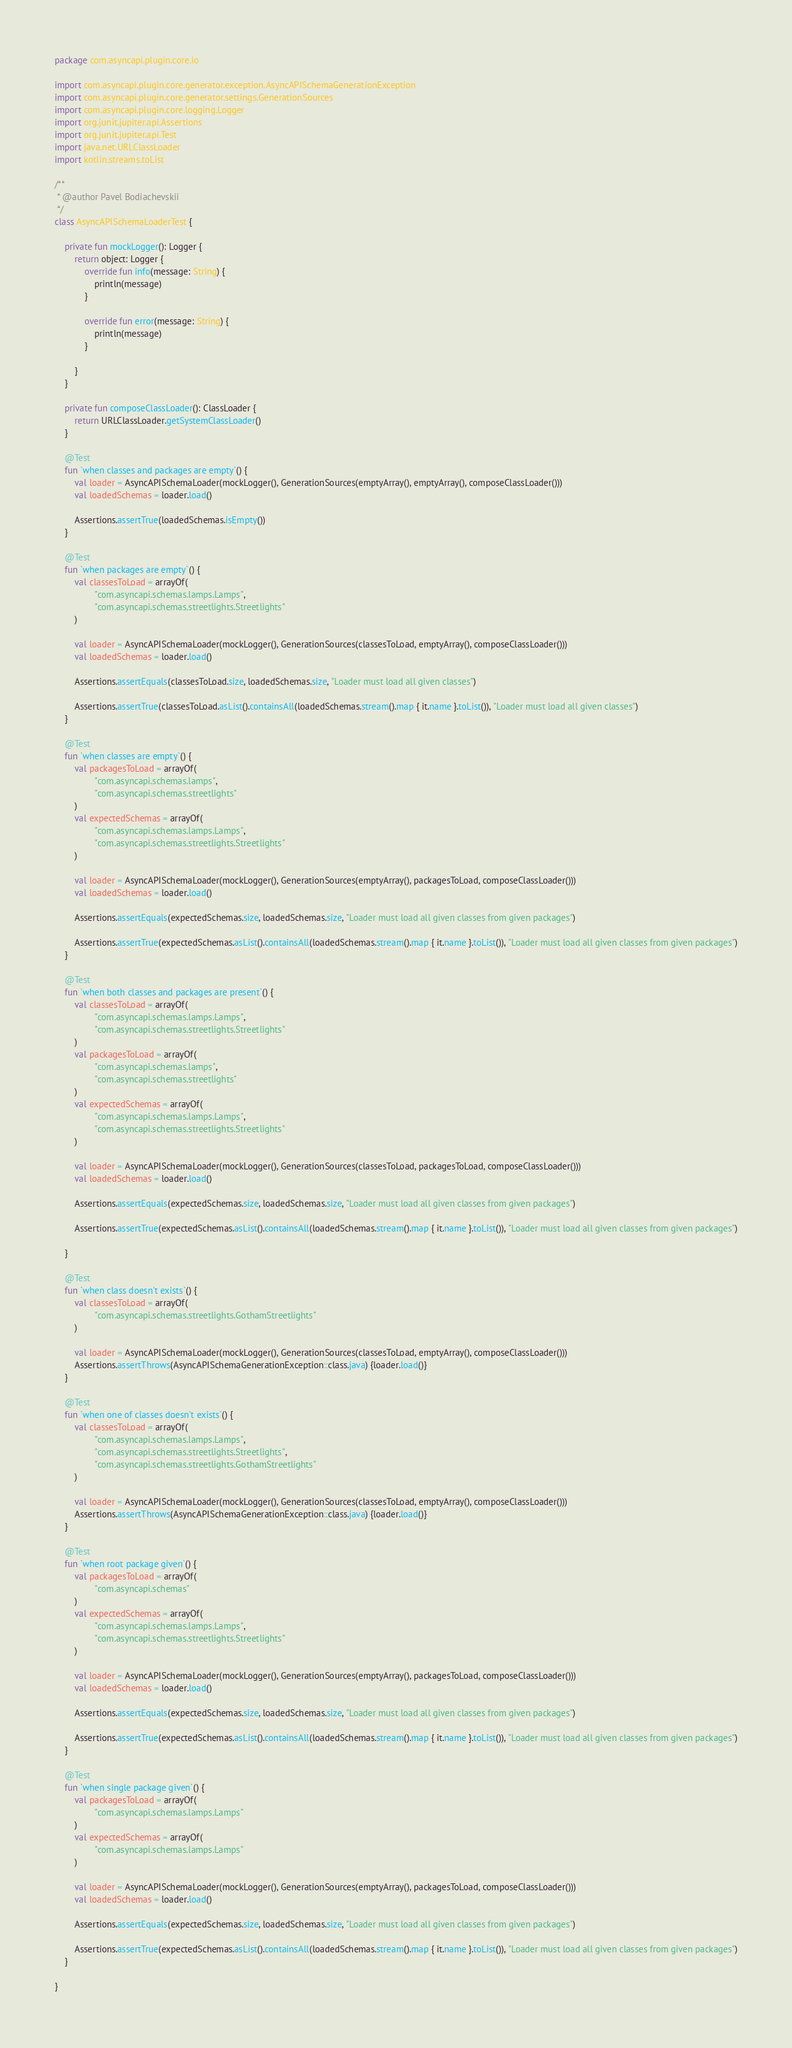<code> <loc_0><loc_0><loc_500><loc_500><_Kotlin_>package com.asyncapi.plugin.core.io

import com.asyncapi.plugin.core.generator.exception.AsyncAPISchemaGenerationException
import com.asyncapi.plugin.core.generator.settings.GenerationSources
import com.asyncapi.plugin.core.logging.Logger
import org.junit.jupiter.api.Assertions
import org.junit.jupiter.api.Test
import java.net.URLClassLoader
import kotlin.streams.toList

/**
 * @author Pavel Bodiachevskii
 */
class AsyncAPISchemaLoaderTest {

    private fun mockLogger(): Logger {
        return object: Logger {
            override fun info(message: String) {
                println(message)
            }

            override fun error(message: String) {
                println(message)
            }

        }
    }

    private fun composeClassLoader(): ClassLoader {
        return URLClassLoader.getSystemClassLoader()
    }

    @Test
    fun `when classes and packages are empty`() {
        val loader = AsyncAPISchemaLoader(mockLogger(), GenerationSources(emptyArray(), emptyArray(), composeClassLoader()))
        val loadedSchemas = loader.load()

        Assertions.assertTrue(loadedSchemas.isEmpty())
    }

    @Test
    fun `when packages are empty`() {
        val classesToLoad = arrayOf(
                "com.asyncapi.schemas.lamps.Lamps",
                "com.asyncapi.schemas.streetlights.Streetlights"
        )

        val loader = AsyncAPISchemaLoader(mockLogger(), GenerationSources(classesToLoad, emptyArray(), composeClassLoader()))
        val loadedSchemas = loader.load()

        Assertions.assertEquals(classesToLoad.size, loadedSchemas.size, "Loader must load all given classes")

        Assertions.assertTrue(classesToLoad.asList().containsAll(loadedSchemas.stream().map { it.name }.toList()), "Loader must load all given classes")
    }

    @Test
    fun `when classes are empty`() {
        val packagesToLoad = arrayOf(
                "com.asyncapi.schemas.lamps",
                "com.asyncapi.schemas.streetlights"
        )
        val expectedSchemas = arrayOf(
                "com.asyncapi.schemas.lamps.Lamps",
                "com.asyncapi.schemas.streetlights.Streetlights"
        )

        val loader = AsyncAPISchemaLoader(mockLogger(), GenerationSources(emptyArray(), packagesToLoad, composeClassLoader()))
        val loadedSchemas = loader.load()

        Assertions.assertEquals(expectedSchemas.size, loadedSchemas.size, "Loader must load all given classes from given packages")

        Assertions.assertTrue(expectedSchemas.asList().containsAll(loadedSchemas.stream().map { it.name }.toList()), "Loader must load all given classes from given packages")
    }

    @Test
    fun `when both classes and packages are present`() {
        val classesToLoad = arrayOf(
                "com.asyncapi.schemas.lamps.Lamps",
                "com.asyncapi.schemas.streetlights.Streetlights"
        )
        val packagesToLoad = arrayOf(
                "com.asyncapi.schemas.lamps",
                "com.asyncapi.schemas.streetlights"
        )
        val expectedSchemas = arrayOf(
                "com.asyncapi.schemas.lamps.Lamps",
                "com.asyncapi.schemas.streetlights.Streetlights"
        )

        val loader = AsyncAPISchemaLoader(mockLogger(), GenerationSources(classesToLoad, packagesToLoad, composeClassLoader()))
        val loadedSchemas = loader.load()

        Assertions.assertEquals(expectedSchemas.size, loadedSchemas.size, "Loader must load all given classes from given packages")

        Assertions.assertTrue(expectedSchemas.asList().containsAll(loadedSchemas.stream().map { it.name }.toList()), "Loader must load all given classes from given packages")

    }

    @Test
    fun `when class doesn't exists`() {
        val classesToLoad = arrayOf(
                "com.asyncapi.schemas.streetlights.GothamStreetlights"
        )

        val loader = AsyncAPISchemaLoader(mockLogger(), GenerationSources(classesToLoad, emptyArray(), composeClassLoader()))
        Assertions.assertThrows(AsyncAPISchemaGenerationException::class.java) {loader.load()}
    }

    @Test
    fun `when one of classes doesn't exists`() {
        val classesToLoad = arrayOf(
                "com.asyncapi.schemas.lamps.Lamps",
                "com.asyncapi.schemas.streetlights.Streetlights",
                "com.asyncapi.schemas.streetlights.GothamStreetlights"
        )

        val loader = AsyncAPISchemaLoader(mockLogger(), GenerationSources(classesToLoad, emptyArray(), composeClassLoader()))
        Assertions.assertThrows(AsyncAPISchemaGenerationException::class.java) {loader.load()}
    }

    @Test
    fun `when root package given`() {
        val packagesToLoad = arrayOf(
                "com.asyncapi.schemas"
        )
        val expectedSchemas = arrayOf(
                "com.asyncapi.schemas.lamps.Lamps",
                "com.asyncapi.schemas.streetlights.Streetlights"
        )

        val loader = AsyncAPISchemaLoader(mockLogger(), GenerationSources(emptyArray(), packagesToLoad, composeClassLoader()))
        val loadedSchemas = loader.load()

        Assertions.assertEquals(expectedSchemas.size, loadedSchemas.size, "Loader must load all given classes from given packages")

        Assertions.assertTrue(expectedSchemas.asList().containsAll(loadedSchemas.stream().map { it.name }.toList()), "Loader must load all given classes from given packages")
    }

    @Test
    fun `when single package given`() {
        val packagesToLoad = arrayOf(
                "com.asyncapi.schemas.lamps.Lamps"
        )
        val expectedSchemas = arrayOf(
                "com.asyncapi.schemas.lamps.Lamps"
        )

        val loader = AsyncAPISchemaLoader(mockLogger(), GenerationSources(emptyArray(), packagesToLoad, composeClassLoader()))
        val loadedSchemas = loader.load()

        Assertions.assertEquals(expectedSchemas.size, loadedSchemas.size, "Loader must load all given classes from given packages")

        Assertions.assertTrue(expectedSchemas.asList().containsAll(loadedSchemas.stream().map { it.name }.toList()), "Loader must load all given classes from given packages")
    }

}</code> 